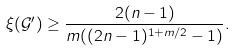Convert formula to latex. <formula><loc_0><loc_0><loc_500><loc_500>\xi ( { \mathcal { G } } ^ { \prime } ) \geq \frac { 2 ( n - 1 ) } { m ( ( 2 n - 1 ) ^ { 1 + m / 2 } - 1 ) } .</formula> 